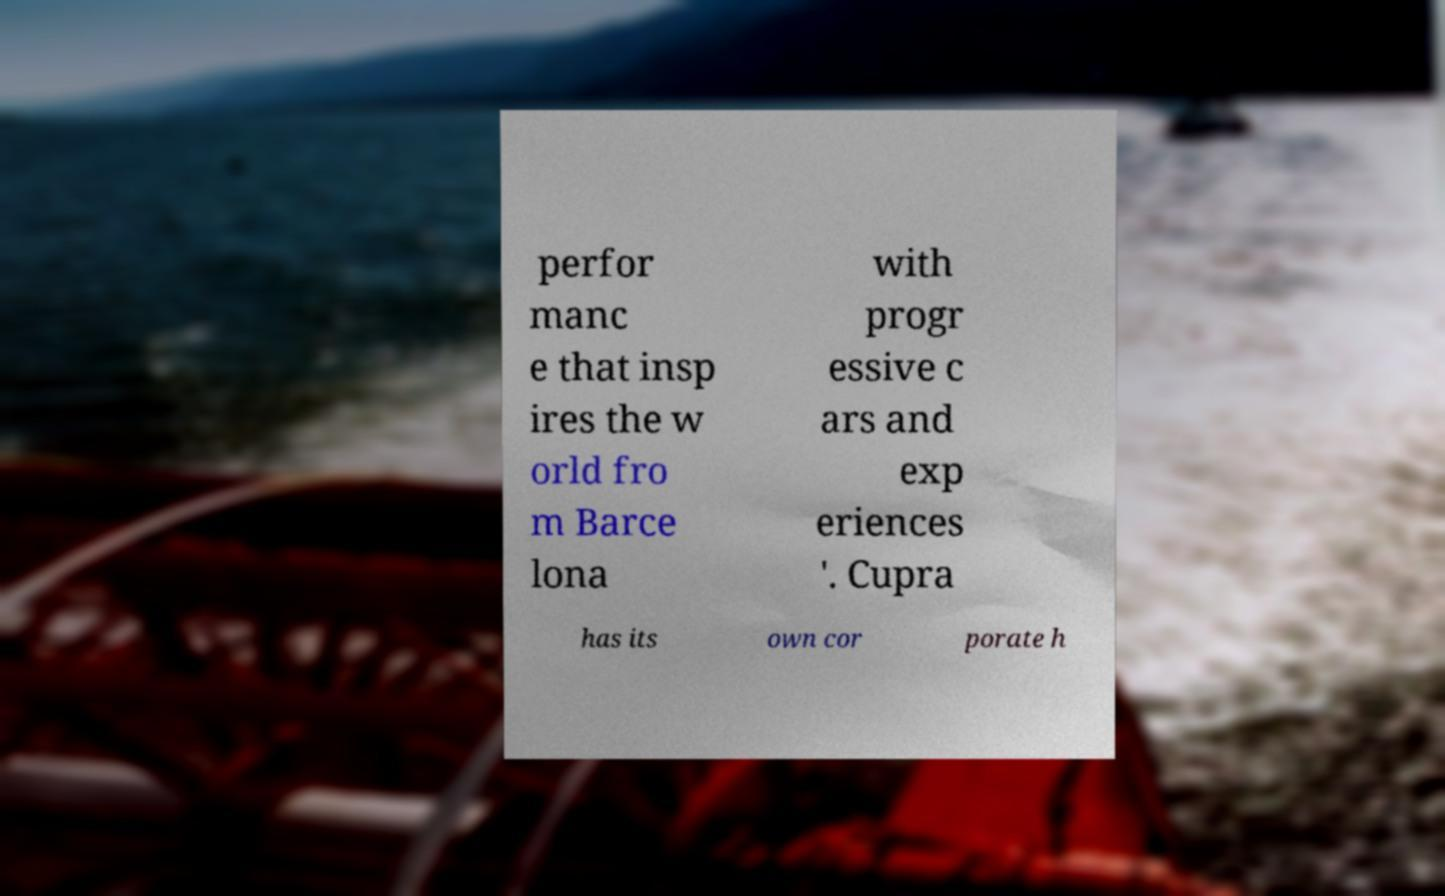Please read and relay the text visible in this image. What does it say? perfor manc e that insp ires the w orld fro m Barce lona with progr essive c ars and exp eriences '. Cupra has its own cor porate h 